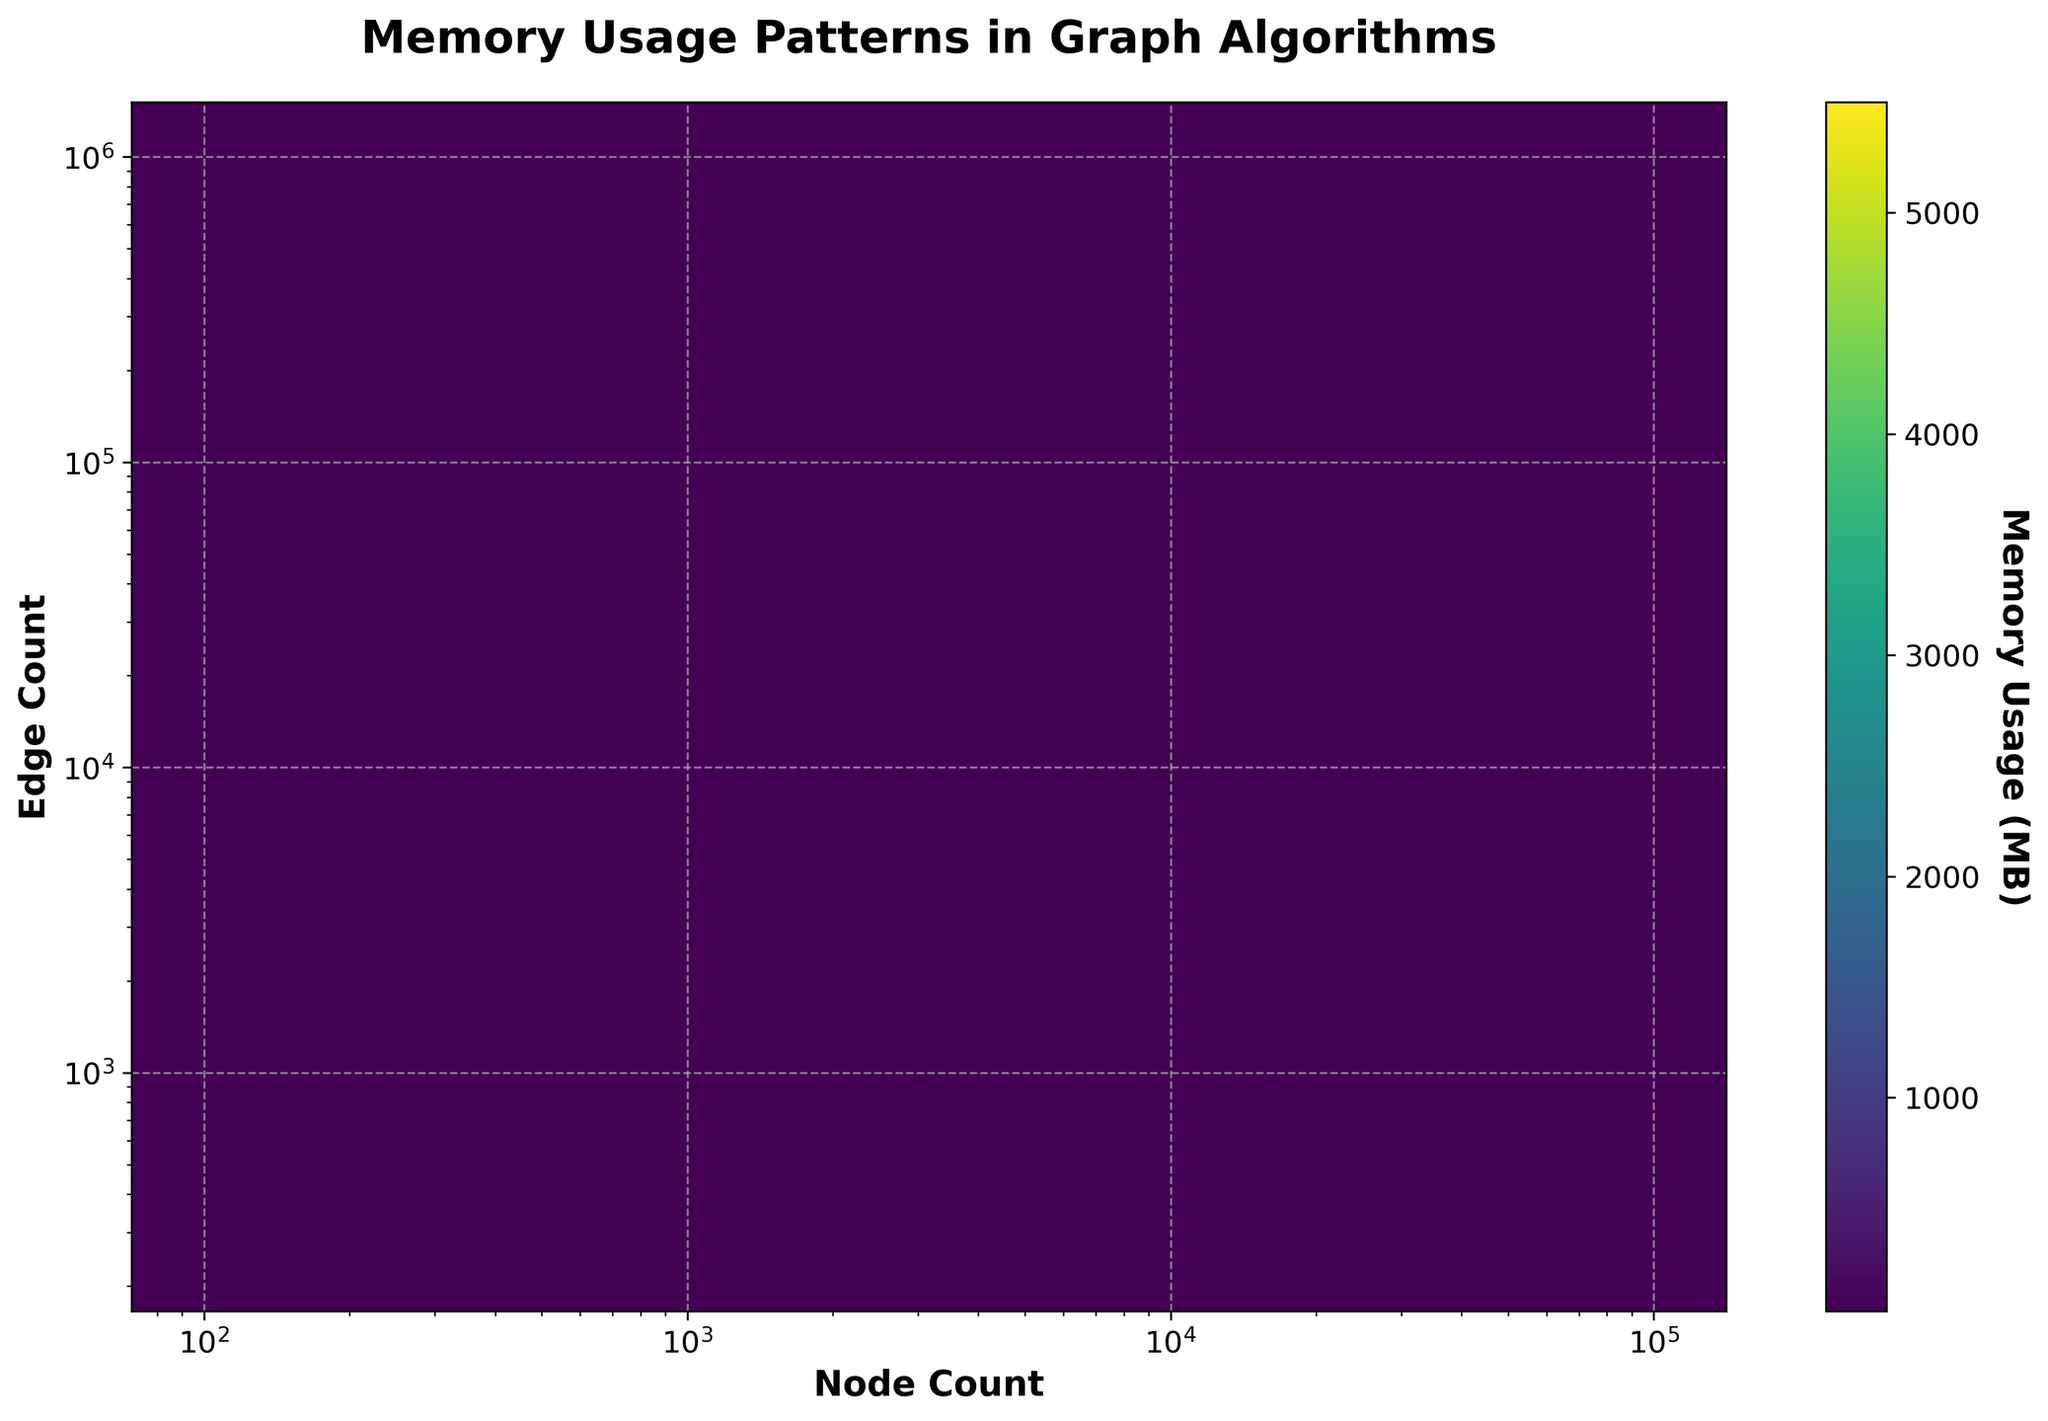What is the title of the hexbin plot? The title of the hexbin plot is usually displayed at the top of the plot, which clearly indicates what the plot represents.
Answer: Memory Usage Patterns in Graph Algorithms What do the x-axis and y-axis represent? The x-axis and y-axis labels are provided to show what each axis represents. In this plot, the x-axis and y-axis labels can tell us about the parameters being mapped.
Answer: Node Count and Edge Count What color represents the highest memory usage on the plot? The color bar to the right of the plot indicates the memory usage range. The color closer to the top of the color bar represents the highest memory usage. In this plot, it would be the color at the top of the viridis colormap.
Answer: Yellow-Green How do the memory usage patterns change with increasing node and edge counts? Observing the placement of hexagons and their colors can show how memory usage varies with differing node and edge counts. As node and edge counts increase, the hexagons tend to have higher memory usage colors.
Answer: Increases Which hexbin grid size is used in the plot? The grid size for hexbin plots is often visible or derived from the density of hexagons in the plot.
Answer: 20 Does the plot use a linear or logarithmic scale for the axes? The scales for the axes can be inferred from the axis ticks and the nature of the increments. If the ticks increase multiplicatively, it’s logarithmic.
Answer: Logarithmic What is the approximate memory usage for a graph with 10,000 nodes and 45,000 edges? By locating the point on the plot where Node Count is 10,000 and Edge Count is 45,000, and observing the color, the memory usage can be estimated using the color bar.
Answer: ~380.6 MB How does the density of hexagonal bins indicate data concentration? The density of hexagonal bins shows how many data points fall into a specific range of node and edge counts, directly mapped through dense clusters or more color intensity.
Answer: Higher density indicates higher data concentration How can we see the variability of memory usage between different node and edge counts in this plot? By identifying various colored hexagons and their distribution across the plot, one can see areas of high and low memory usage, indicating variability.
Answer: Color and placement of hexagons By referring to the color bar, what is the memory usage range captured in this plot? The color bar provides the minimum and maximum values of the memory usage in megabytes. Checking the bottom and top ends of the color bar will show the range.
Answer: 5.2 MB - 5500.8 MB 